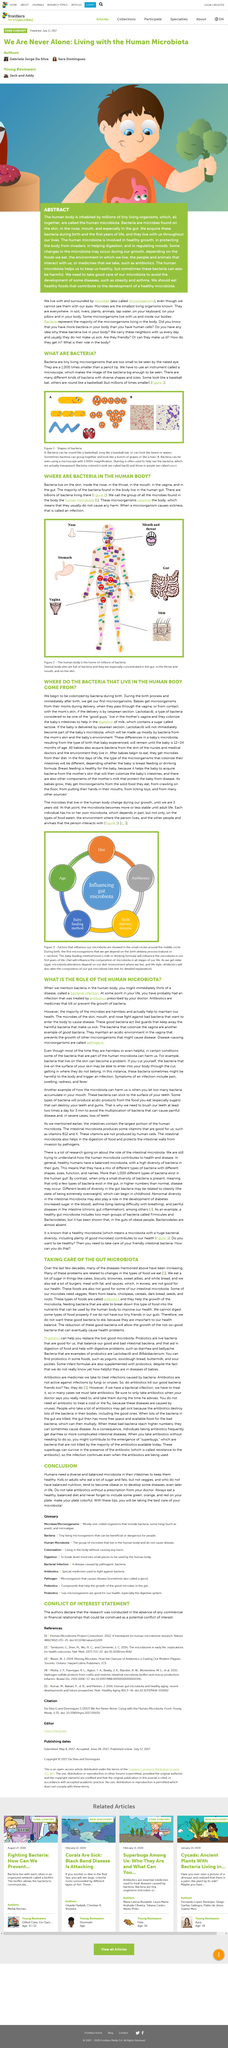List a handful of essential elements in this visual. In conclusion, it is imperative to maintain a diverse microbiota in the intestines for optimal health. It is recommended that the colors present on your plate should consist of green, orange, and red. It is possible to view bacteria using a microscope, as demonstrated by the sentence 'A microscope can be used to see bacteria.' It is a fact that not all microbes are harmful, with the majority being harmless and beneficial to maintaining good health. Pathogens can cause bacterial infections and make individuals sick, as they are harmful bacteria that can infect and damage cells and tissues in the body. 